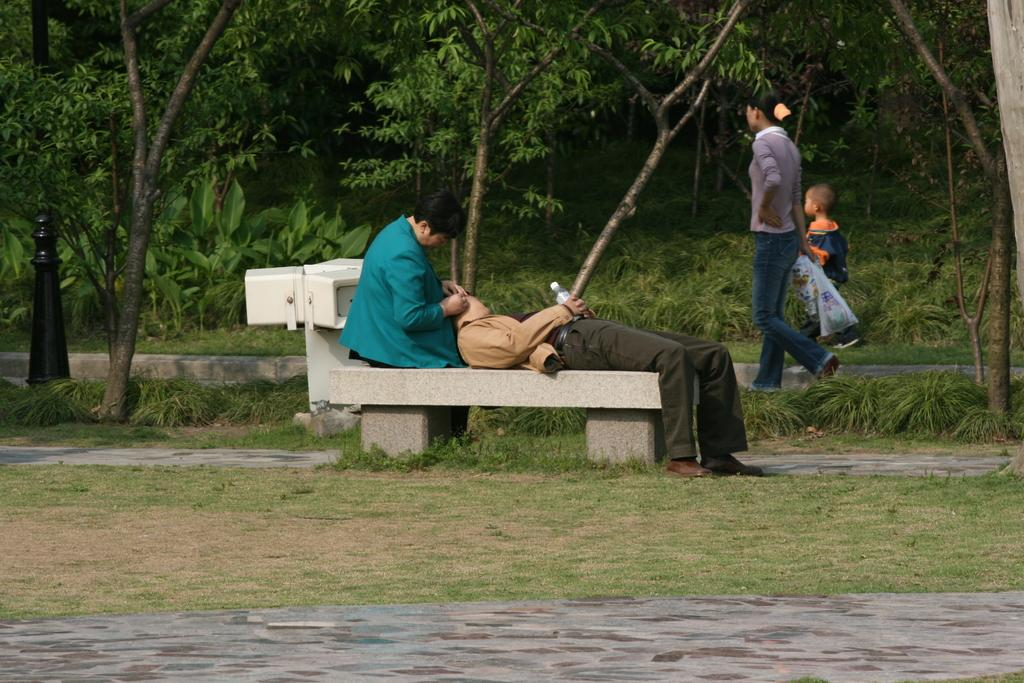How many people are in the image? There are three persons in the image. Can you describe the age of one of the persons? There is a child in the image. What are two of the persons doing in the image? Two persons are sitting on a bench. What can be seen in the background of the image? There are trees visible in the background of the image. What type of camera can be seen in the hands of the child in the image? There is no camera present in the image; the child is not holding anything. 